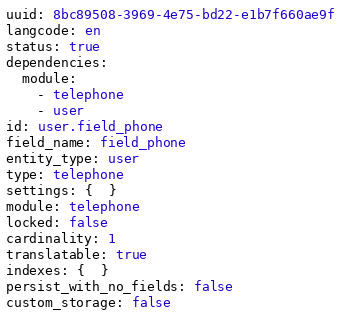<code> <loc_0><loc_0><loc_500><loc_500><_YAML_>uuid: 8bc89508-3969-4e75-bd22-e1b7f660ae9f
langcode: en
status: true
dependencies:
  module:
    - telephone
    - user
id: user.field_phone
field_name: field_phone
entity_type: user
type: telephone
settings: {  }
module: telephone
locked: false
cardinality: 1
translatable: true
indexes: {  }
persist_with_no_fields: false
custom_storage: false
</code> 